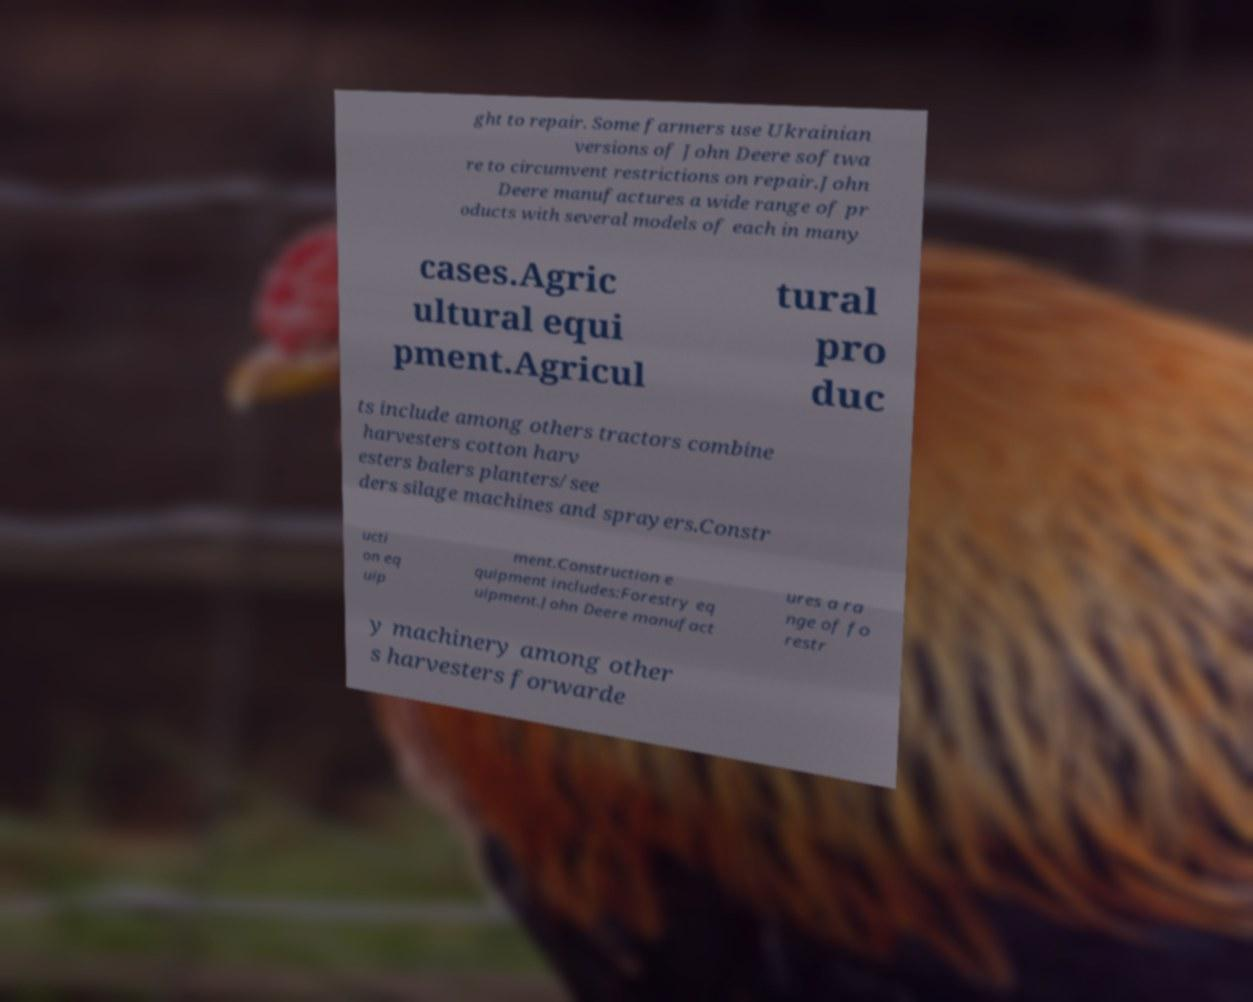Can you accurately transcribe the text from the provided image for me? ght to repair. Some farmers use Ukrainian versions of John Deere softwa re to circumvent restrictions on repair.John Deere manufactures a wide range of pr oducts with several models of each in many cases.Agric ultural equi pment.Agricul tural pro duc ts include among others tractors combine harvesters cotton harv esters balers planters/see ders silage machines and sprayers.Constr ucti on eq uip ment.Construction e quipment includes:Forestry eq uipment.John Deere manufact ures a ra nge of fo restr y machinery among other s harvesters forwarde 